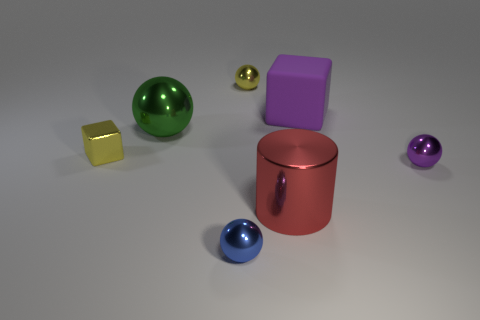How many objects are balls behind the red metallic object or big metal cylinders?
Your answer should be compact. 4. The big sphere is what color?
Provide a succinct answer. Green. What material is the cube that is behind the tiny block?
Offer a very short reply. Rubber. There is a blue shiny object; is its shape the same as the large shiny object that is behind the tiny purple sphere?
Keep it short and to the point. Yes. Are there more small yellow things than tiny blue objects?
Ensure brevity in your answer.  Yes. Is there anything else of the same color as the large rubber block?
Ensure brevity in your answer.  Yes. The other big thing that is the same material as the large red thing is what shape?
Make the answer very short. Sphere. There is a cube right of the ball behind the rubber cube; what is it made of?
Offer a very short reply. Rubber. There is a small yellow metal thing behind the big purple matte block; does it have the same shape as the red thing?
Offer a very short reply. No. Is the number of objects that are on the right side of the yellow shiny sphere greater than the number of metal cubes?
Provide a short and direct response. Yes. 